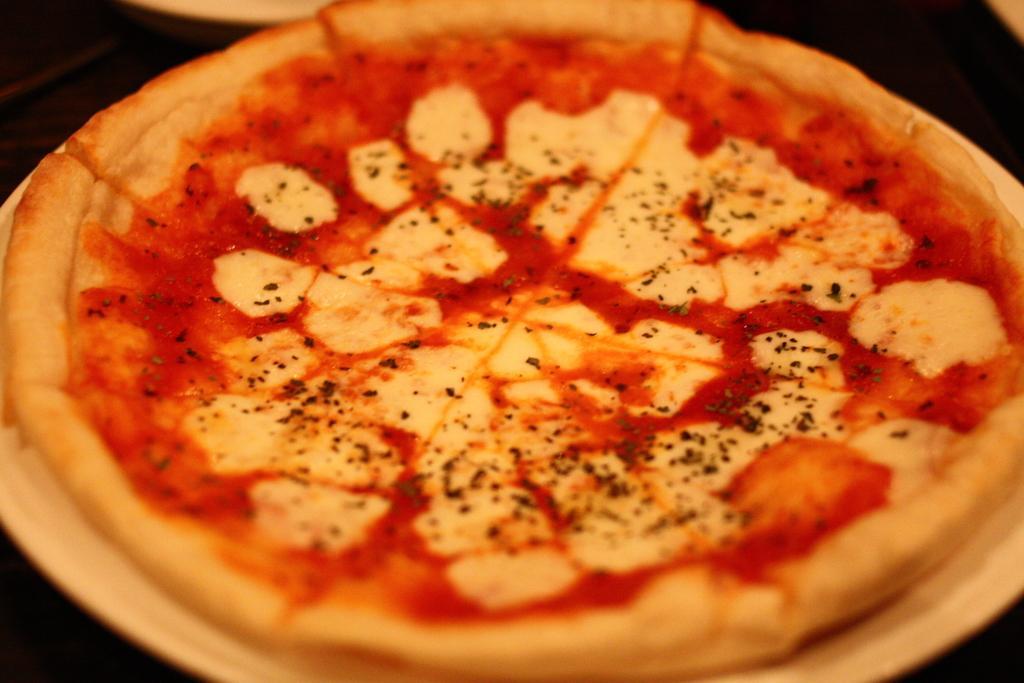Please provide a concise description of this image. In this picture we can see a plate in the front, there is pizza present in this plate, we can see a dark background. 